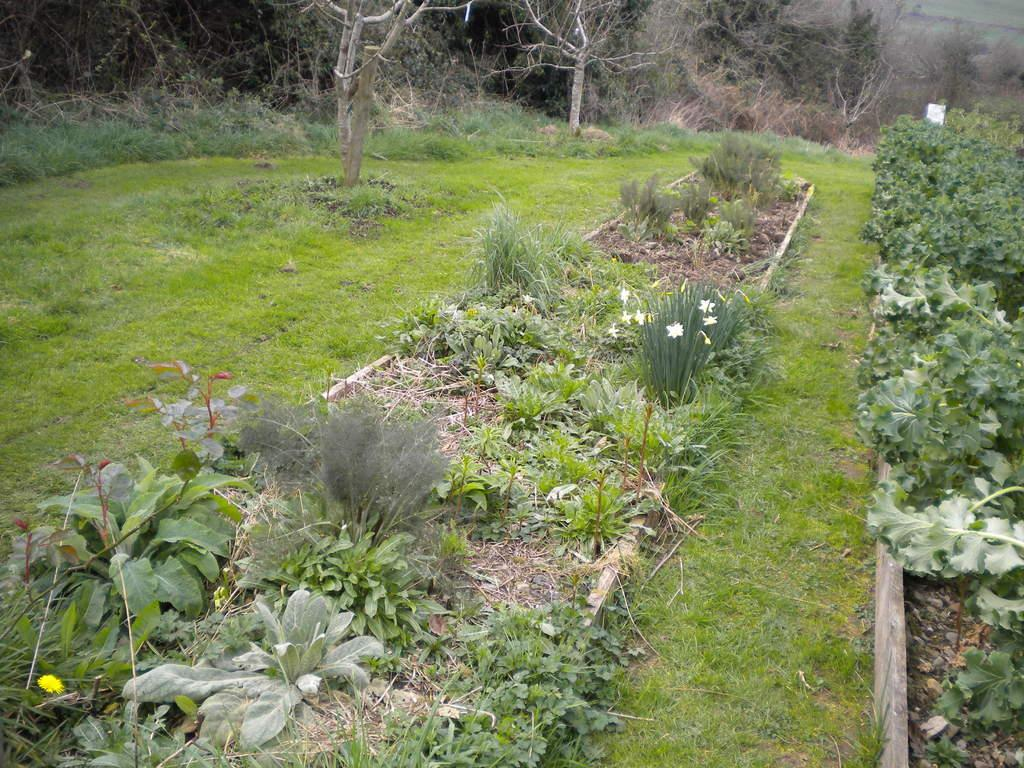What type of vegetation can be seen in the image? There are plants in the image. What is present on the surface at the bottom of the image? There is grass on the surface at the bottom of the image. What can be seen in the background of the image? There are trees in the background of the image. How many cakes are placed on the grass in the image? There are no cakes present in the image; it features plants, grass, and trees. 